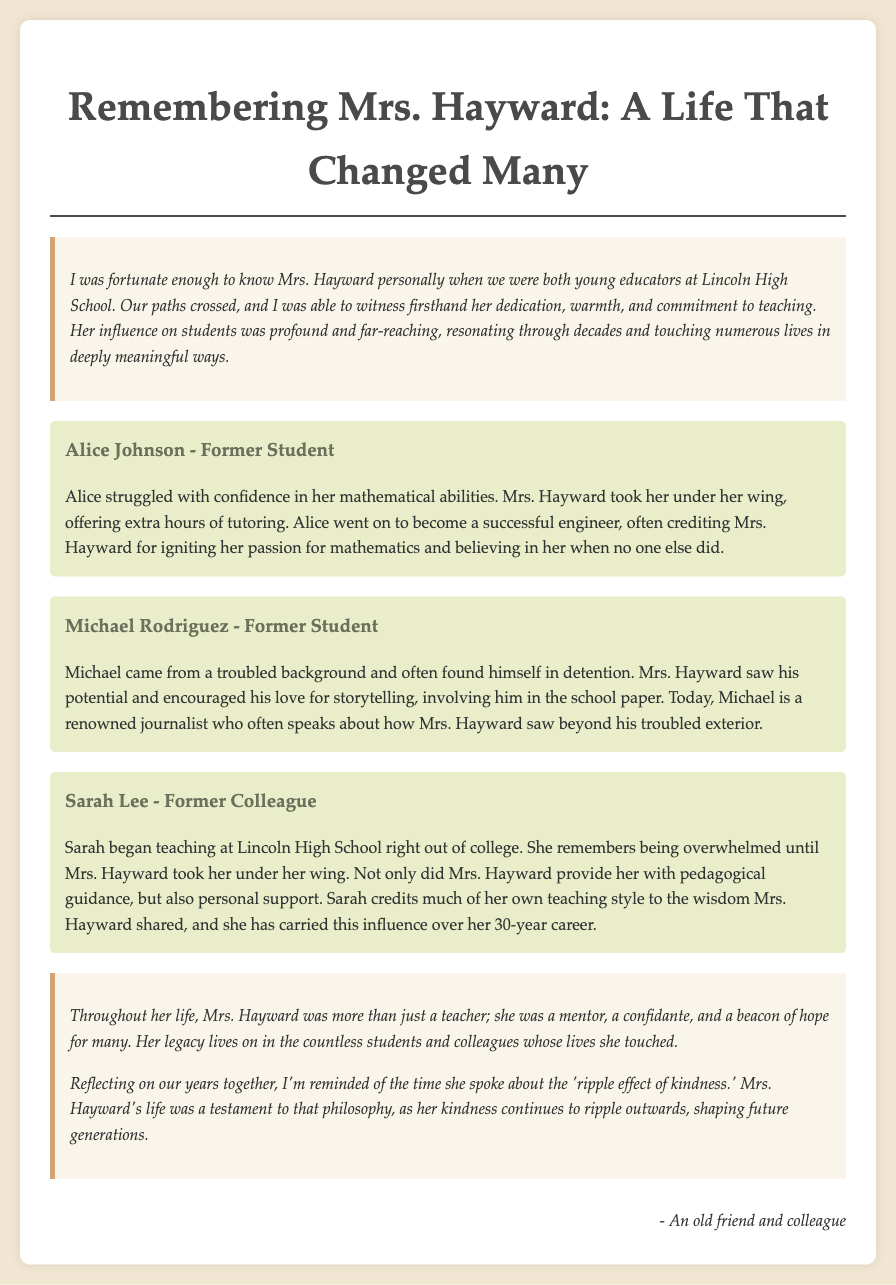what is the title of the document? The title is located at the top of the document, representing the theme of the eulogy.
Answer: Remembering Mrs. Hayward: A Life That Changed Many who took Alice Johnson under her wing? This information is mentioned in the section about Alice Johnson, highlighting Mrs. Hayward's role in her education.
Answer: Mrs. Hayward what profession did Alice Johnson pursue? Alice's success story culminates in her career, which is explicitly stated.
Answer: Engineer which school did Mrs. Hayward and the narrator work at? The school is referred to multiple times and is a key detail in the introduction of the document.
Answer: Lincoln High School how long did Sarah Lee credit Mrs. Hayward's influence on her career? This is a reflection mentioned in Sarah's story, indicating Sarah's appreciation for Mrs. Hayward.
Answer: 30-year career what did Michael Rodriguez excel in after school? Michael's career path is detailed, showcasing the impact Mrs. Hayward had on his life choices.
Answer: Journalist what is a key theme reflected in Ms. Hayward's approach to teaching? The theme is summarized in the conclusion, emphasizing Mrs. Hayward's philosophy.
Answer: Ripple effect of kindness who is the author of the eulogy? The document concludes with a personal signature indicating the author's identity.
Answer: An old friend and colleague 